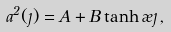Convert formula to latex. <formula><loc_0><loc_0><loc_500><loc_500>a ^ { 2 } ( \eta ) = A + B \tanh \rho \eta \, ,</formula> 